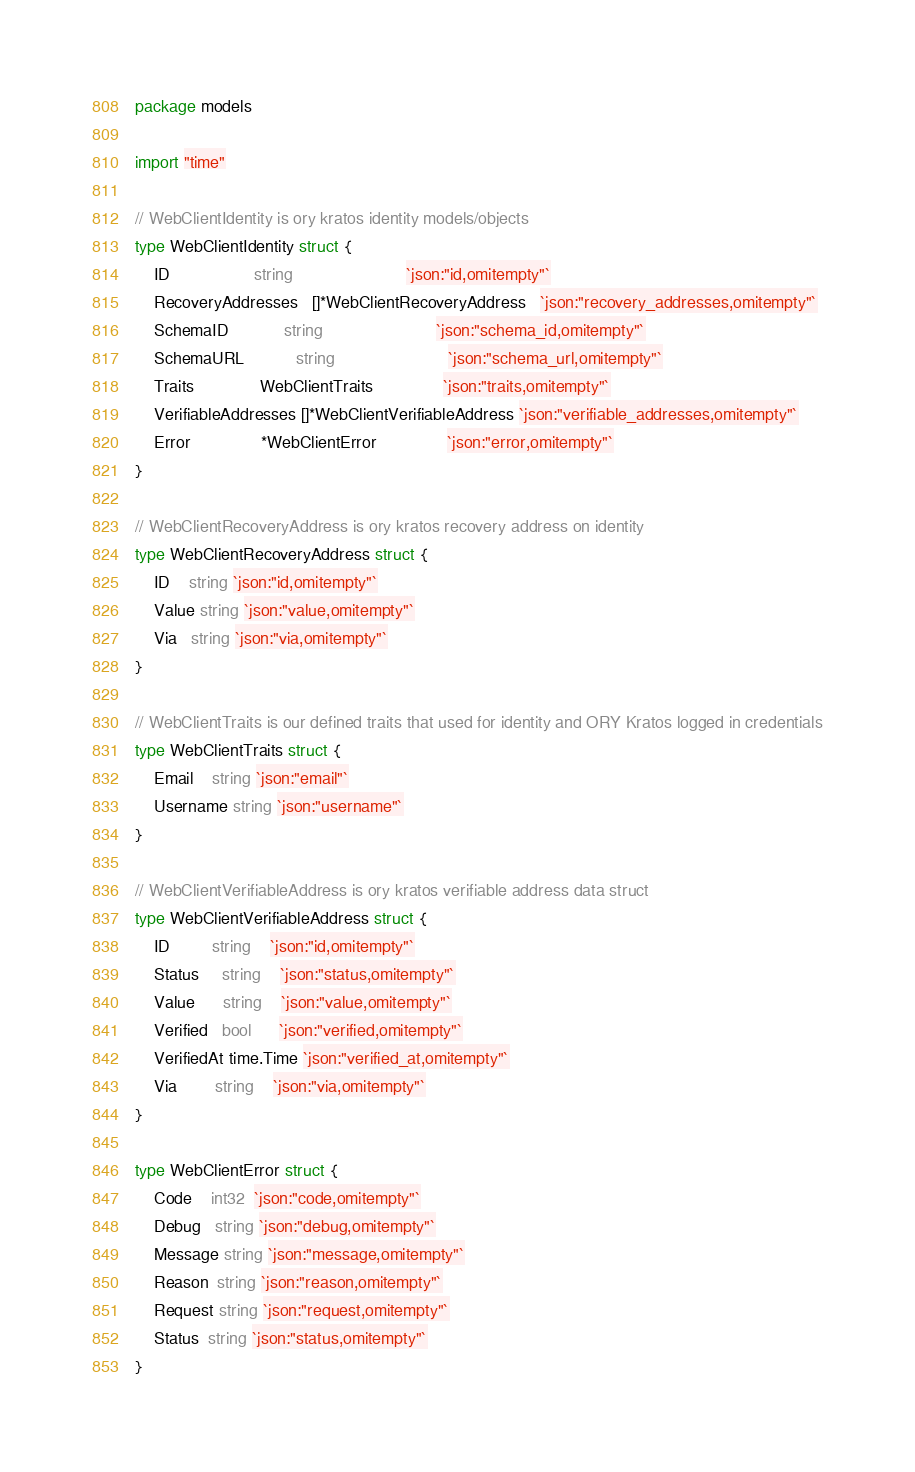<code> <loc_0><loc_0><loc_500><loc_500><_Go_>package models

import "time"

// WebClientIdentity is ory kratos identity models/objects
type WebClientIdentity struct {
	ID                  string                        `json:"id,omitempty"`
	RecoveryAddresses   []*WebClientRecoveryAddress   `json:"recovery_addresses,omitempty"`
	SchemaID            string                        `json:"schema_id,omitempty"`
	SchemaURL           string                        `json:"schema_url,omitempty"`
	Traits              WebClientTraits               `json:"traits,omitempty"`
	VerifiableAddresses []*WebClientVerifiableAddress `json:"verifiable_addresses,omitempty"`
	Error               *WebClientError               `json:"error,omitempty"`
}

// WebClientRecoveryAddress is ory kratos recovery address on identity
type WebClientRecoveryAddress struct {
	ID    string `json:"id,omitempty"`
	Value string `json:"value,omitempty"`
	Via   string `json:"via,omitempty"`
}

// WebClientTraits is our defined traits that used for identity and ORY Kratos logged in credentials
type WebClientTraits struct {
	Email    string `json:"email"`
	Username string `json:"username"`
}

// WebClientVerifiableAddress is ory kratos verifiable address data struct
type WebClientVerifiableAddress struct {
	ID         string    `json:"id,omitempty"`
	Status     string    `json:"status,omitempty"`
	Value      string    `json:"value,omitempty"`
	Verified   bool      `json:"verified,omitempty"`
	VerifiedAt time.Time `json:"verified_at,omitempty"`
	Via        string    `json:"via,omitempty"`
}

type WebClientError struct {
	Code    int32  `json:"code,omitempty"`
	Debug   string `json:"debug,omitempty"`
	Message string `json:"message,omitempty"`
	Reason  string `json:"reason,omitempty"`
	Request string `json:"request,omitempty"`
	Status  string `json:"status,omitempty"`
}
</code> 